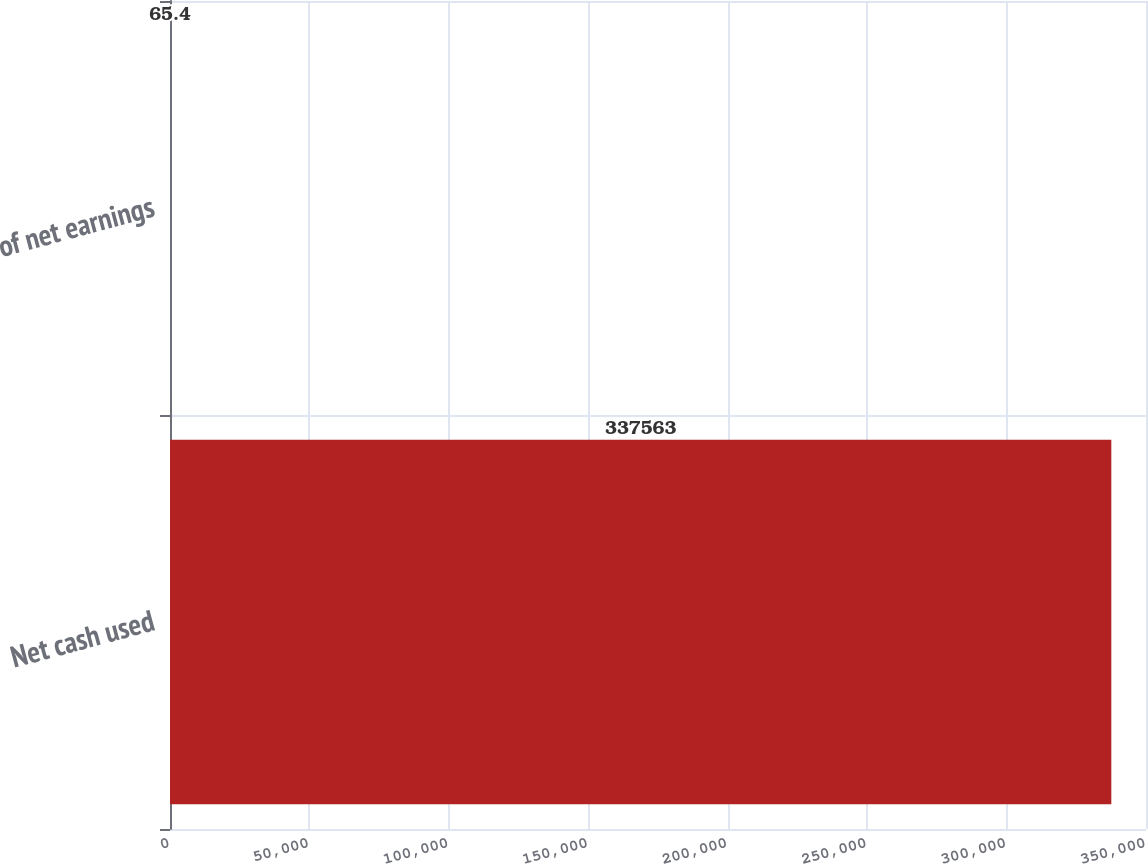<chart> <loc_0><loc_0><loc_500><loc_500><bar_chart><fcel>Net cash used<fcel>of net earnings<nl><fcel>337563<fcel>65.4<nl></chart> 